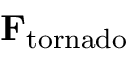Convert formula to latex. <formula><loc_0><loc_0><loc_500><loc_500>F _ { t o r n a d o }</formula> 